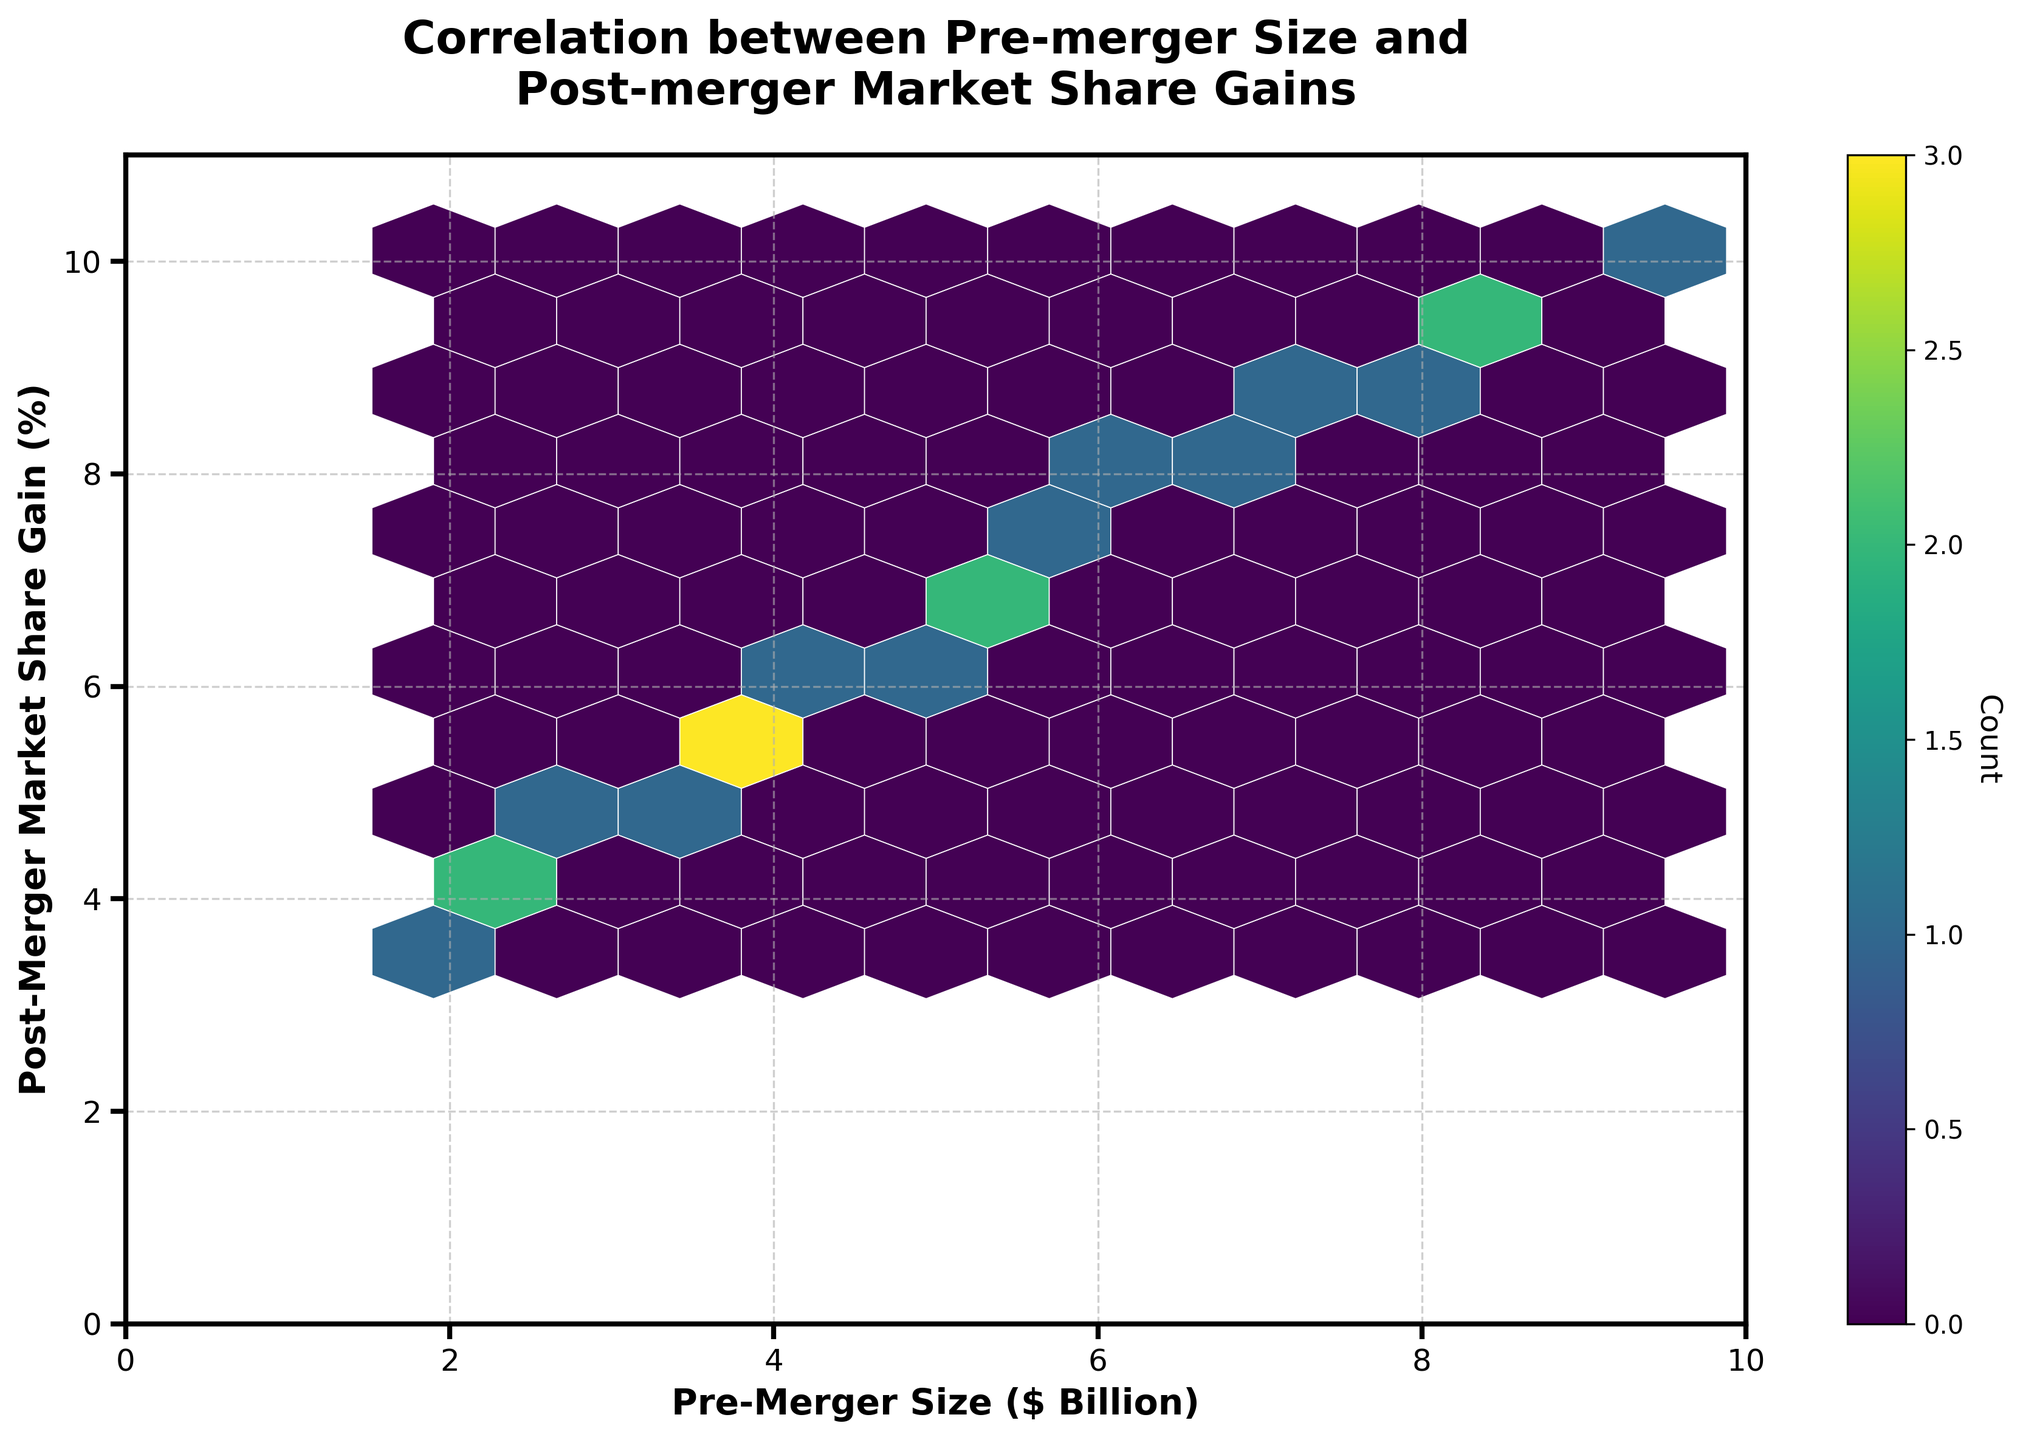What is the title of the plot? The title is displayed at the top of the plot and typically describes what the plot is about. In this case, the title is clearly shown above the graph.
Answer: Correlation between Pre-merger Size and Post-merger Market Share Gains What are the labels of the axes? Axis labels describe what each axis represents. The x-axis usually has a label at the bottom, and the y-axis label is along the left side of the plot.
Answer: Pre-Merger Size ($ Billion) and Post-Merger Market Share Gain (%) What color represents the highest count in the hexbins? The hexbin plot uses a color gradient to represent different counts of data points. The color representing the highest count can be identified by looking at the color bar on the side.
Answer: Dark Purple Are there more data points with a pre-merger size less than $5 billion or greater than $5 billion? Count the number of hexagons on either side of the $5 billion mark on the x-axis to determine which side has more data points.
Answer: Greater than $5 billion What is the range of post-merger market share gain percentages displayed in the plot? The range of values on the y-axis shows the spectrum of post-merger market share gains observed. The minimum and maximum values on this axis delineate the range.
Answer: 0% to 11% Which pre-merger size group shows the highest concentration of data points? Look for the area with the densest cluster of hexagons (deepest color), which indicates the highest concentration of data points.
Answer: Between $5 billion and $7 billion Do companies with a pre-merger size between $7 billion and $10 billion generally show a higher post-merger market share gain compared to those between $2 billion and $5 billion? Compare the color intensity within the hexagons in the specified ranges. Higher color intensity suggests a higher count and can indicate a general trend.
Answer: Yes What is the average pre-merger size of the companies in the dataset? Sum all pre-merger sizes and divide by the number of data points. The data shows there are 20 points.
Answer: (2.5+5.1+3.7+8.2+1.9+6.4+4.8+7.3+3.2+9.5+2.8+5.7+4.1+6.9+3.9+8.7+2.3+7.8+5.3+4.5) / 20 = 109.5 / 20 = 5.475 Is there a positive correlation between pre-merger size and post-merger market share gain? A positive correlation is indicated by an upward slope from left to right, meaning as one variable increases, so does the other. By observing the spread of hexagons and their colors, we can determine the correlation.
Answer: Yes How many hexagons are shown on the plot? Count the number of hexagonal bins present in the visual plot. This requires systematically scanning the plot.
Answer: 28 